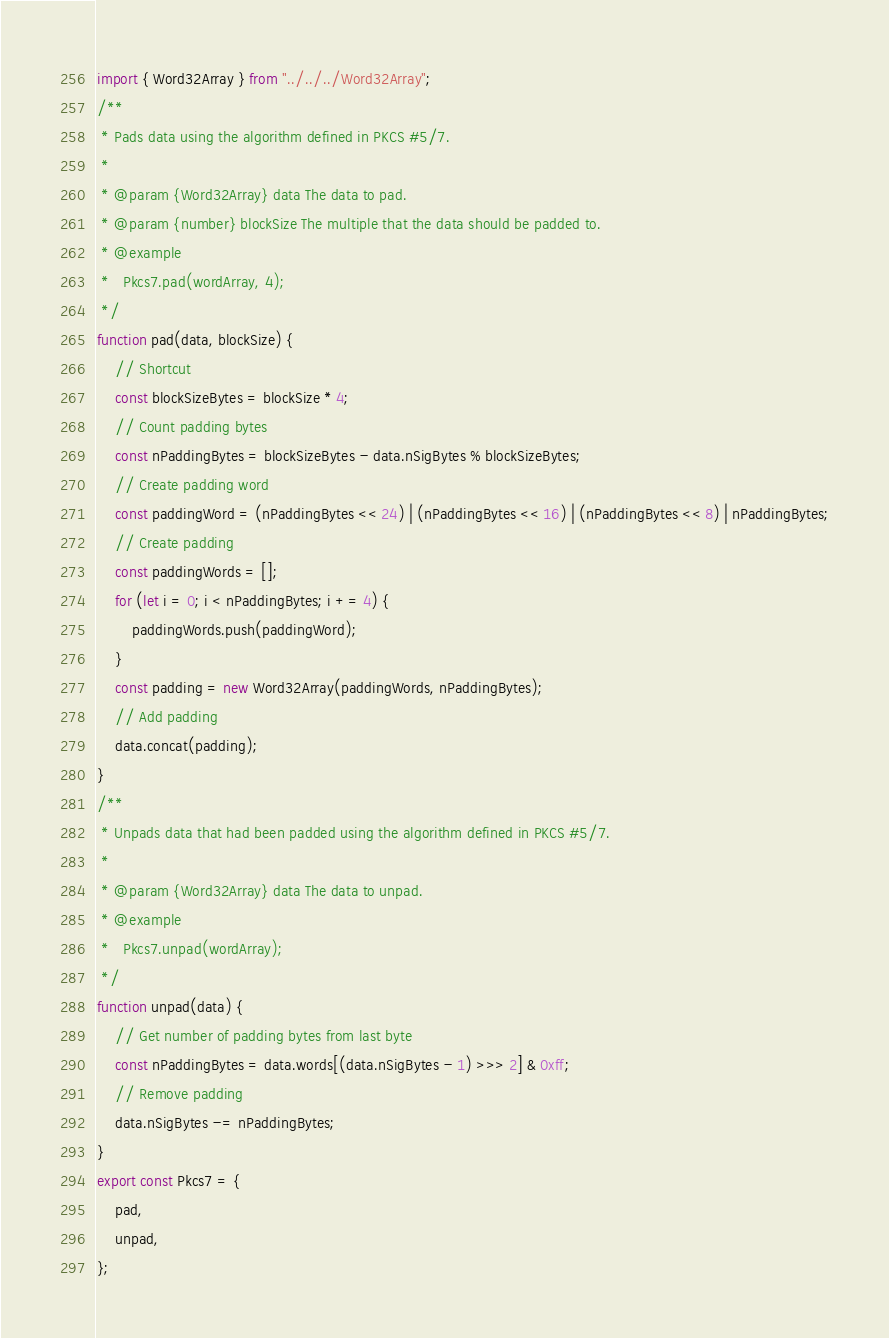<code> <loc_0><loc_0><loc_500><loc_500><_JavaScript_>import { Word32Array } from "../../../Word32Array";
/**
 * Pads data using the algorithm defined in PKCS #5/7.
 *
 * @param {Word32Array} data The data to pad.
 * @param {number} blockSize The multiple that the data should be padded to.
 * @example
 *   Pkcs7.pad(wordArray, 4);
 */
function pad(data, blockSize) {
    // Shortcut
    const blockSizeBytes = blockSize * 4;
    // Count padding bytes
    const nPaddingBytes = blockSizeBytes - data.nSigBytes % blockSizeBytes;
    // Create padding word
    const paddingWord = (nPaddingBytes << 24) | (nPaddingBytes << 16) | (nPaddingBytes << 8) | nPaddingBytes;
    // Create padding
    const paddingWords = [];
    for (let i = 0; i < nPaddingBytes; i += 4) {
        paddingWords.push(paddingWord);
    }
    const padding = new Word32Array(paddingWords, nPaddingBytes);
    // Add padding
    data.concat(padding);
}
/**
 * Unpads data that had been padded using the algorithm defined in PKCS #5/7.
 *
 * @param {Word32Array} data The data to unpad.
 * @example
 *   Pkcs7.unpad(wordArray);
 */
function unpad(data) {
    // Get number of padding bytes from last byte
    const nPaddingBytes = data.words[(data.nSigBytes - 1) >>> 2] & 0xff;
    // Remove padding
    data.nSigBytes -= nPaddingBytes;
}
export const Pkcs7 = {
    pad,
    unpad,
};
</code> 